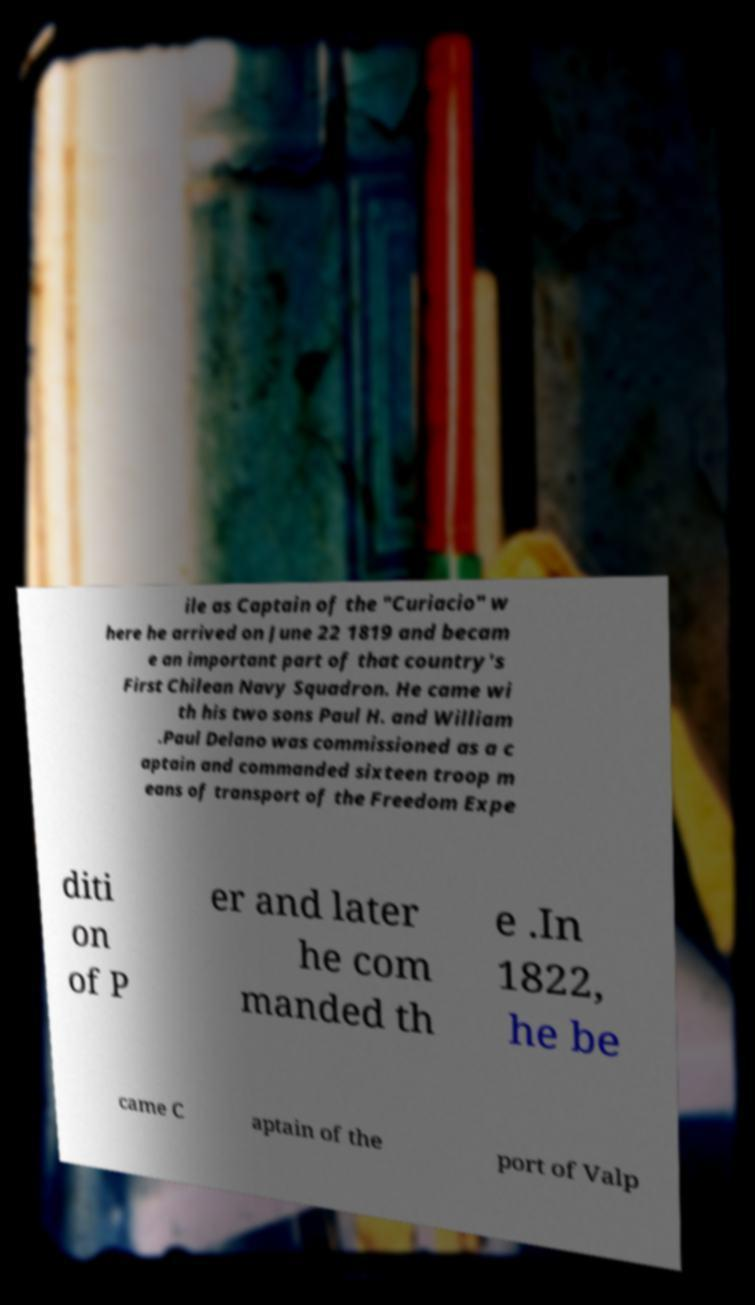Could you extract and type out the text from this image? ile as Captain of the "Curiacio" w here he arrived on June 22 1819 and becam e an important part of that country's First Chilean Navy Squadron. He came wi th his two sons Paul H. and William .Paul Delano was commissioned as a c aptain and commanded sixteen troop m eans of transport of the Freedom Expe diti on of P er and later he com manded th e .In 1822, he be came C aptain of the port of Valp 